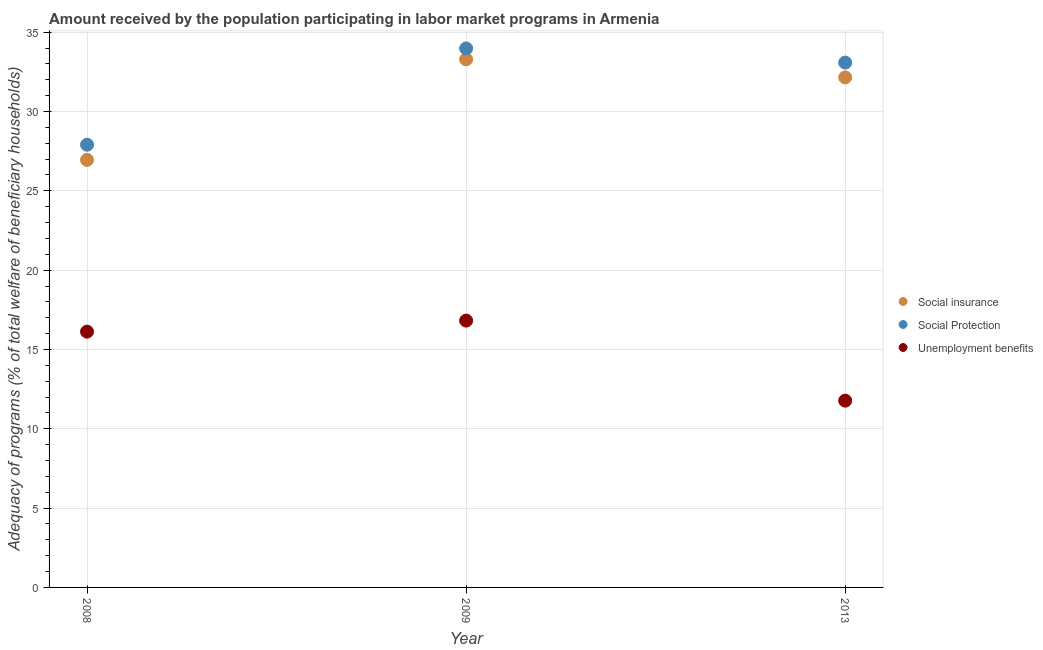How many different coloured dotlines are there?
Make the answer very short. 3. What is the amount received by the population participating in unemployment benefits programs in 2008?
Your answer should be very brief. 16.12. Across all years, what is the maximum amount received by the population participating in social insurance programs?
Your answer should be very brief. 33.29. Across all years, what is the minimum amount received by the population participating in social protection programs?
Your answer should be very brief. 27.91. In which year was the amount received by the population participating in unemployment benefits programs maximum?
Give a very brief answer. 2009. In which year was the amount received by the population participating in social insurance programs minimum?
Your response must be concise. 2008. What is the total amount received by the population participating in social protection programs in the graph?
Make the answer very short. 94.97. What is the difference between the amount received by the population participating in social protection programs in 2009 and that in 2013?
Give a very brief answer. 0.89. What is the difference between the amount received by the population participating in unemployment benefits programs in 2013 and the amount received by the population participating in social protection programs in 2008?
Provide a short and direct response. -16.13. What is the average amount received by the population participating in social insurance programs per year?
Offer a terse response. 30.8. In the year 2013, what is the difference between the amount received by the population participating in unemployment benefits programs and amount received by the population participating in social insurance programs?
Ensure brevity in your answer.  -20.37. In how many years, is the amount received by the population participating in social insurance programs greater than 12 %?
Your answer should be very brief. 3. What is the ratio of the amount received by the population participating in unemployment benefits programs in 2008 to that in 2009?
Offer a terse response. 0.96. Is the amount received by the population participating in social protection programs in 2008 less than that in 2009?
Your answer should be very brief. Yes. Is the difference between the amount received by the population participating in social insurance programs in 2008 and 2013 greater than the difference between the amount received by the population participating in unemployment benefits programs in 2008 and 2013?
Make the answer very short. No. What is the difference between the highest and the second highest amount received by the population participating in social protection programs?
Keep it short and to the point. 0.89. What is the difference between the highest and the lowest amount received by the population participating in social insurance programs?
Keep it short and to the point. 6.34. In how many years, is the amount received by the population participating in unemployment benefits programs greater than the average amount received by the population participating in unemployment benefits programs taken over all years?
Offer a very short reply. 2. Is the sum of the amount received by the population participating in social insurance programs in 2009 and 2013 greater than the maximum amount received by the population participating in unemployment benefits programs across all years?
Offer a terse response. Yes. Does the amount received by the population participating in unemployment benefits programs monotonically increase over the years?
Make the answer very short. No. Is the amount received by the population participating in social insurance programs strictly greater than the amount received by the population participating in unemployment benefits programs over the years?
Give a very brief answer. Yes. Is the amount received by the population participating in social insurance programs strictly less than the amount received by the population participating in unemployment benefits programs over the years?
Ensure brevity in your answer.  No. How many dotlines are there?
Make the answer very short. 3. What is the difference between two consecutive major ticks on the Y-axis?
Keep it short and to the point. 5. Does the graph contain any zero values?
Ensure brevity in your answer.  No. What is the title of the graph?
Your answer should be compact. Amount received by the population participating in labor market programs in Armenia. What is the label or title of the X-axis?
Your answer should be very brief. Year. What is the label or title of the Y-axis?
Offer a very short reply. Adequacy of programs (% of total welfare of beneficiary households). What is the Adequacy of programs (% of total welfare of beneficiary households) in Social insurance in 2008?
Make the answer very short. 26.95. What is the Adequacy of programs (% of total welfare of beneficiary households) in Social Protection in 2008?
Provide a short and direct response. 27.91. What is the Adequacy of programs (% of total welfare of beneficiary households) in Unemployment benefits in 2008?
Provide a succinct answer. 16.12. What is the Adequacy of programs (% of total welfare of beneficiary households) in Social insurance in 2009?
Your answer should be very brief. 33.29. What is the Adequacy of programs (% of total welfare of beneficiary households) of Social Protection in 2009?
Ensure brevity in your answer.  33.98. What is the Adequacy of programs (% of total welfare of beneficiary households) in Unemployment benefits in 2009?
Offer a terse response. 16.82. What is the Adequacy of programs (% of total welfare of beneficiary households) in Social insurance in 2013?
Offer a terse response. 32.15. What is the Adequacy of programs (% of total welfare of beneficiary households) of Social Protection in 2013?
Make the answer very short. 33.08. What is the Adequacy of programs (% of total welfare of beneficiary households) in Unemployment benefits in 2013?
Give a very brief answer. 11.77. Across all years, what is the maximum Adequacy of programs (% of total welfare of beneficiary households) in Social insurance?
Provide a short and direct response. 33.29. Across all years, what is the maximum Adequacy of programs (% of total welfare of beneficiary households) in Social Protection?
Your response must be concise. 33.98. Across all years, what is the maximum Adequacy of programs (% of total welfare of beneficiary households) of Unemployment benefits?
Your response must be concise. 16.82. Across all years, what is the minimum Adequacy of programs (% of total welfare of beneficiary households) in Social insurance?
Offer a terse response. 26.95. Across all years, what is the minimum Adequacy of programs (% of total welfare of beneficiary households) of Social Protection?
Make the answer very short. 27.91. Across all years, what is the minimum Adequacy of programs (% of total welfare of beneficiary households) of Unemployment benefits?
Keep it short and to the point. 11.77. What is the total Adequacy of programs (% of total welfare of beneficiary households) in Social insurance in the graph?
Your answer should be compact. 92.39. What is the total Adequacy of programs (% of total welfare of beneficiary households) in Social Protection in the graph?
Your answer should be very brief. 94.97. What is the total Adequacy of programs (% of total welfare of beneficiary households) in Unemployment benefits in the graph?
Offer a terse response. 44.72. What is the difference between the Adequacy of programs (% of total welfare of beneficiary households) in Social insurance in 2008 and that in 2009?
Your answer should be compact. -6.34. What is the difference between the Adequacy of programs (% of total welfare of beneficiary households) in Social Protection in 2008 and that in 2009?
Your response must be concise. -6.07. What is the difference between the Adequacy of programs (% of total welfare of beneficiary households) in Unemployment benefits in 2008 and that in 2009?
Your response must be concise. -0.7. What is the difference between the Adequacy of programs (% of total welfare of beneficiary households) of Social insurance in 2008 and that in 2013?
Provide a short and direct response. -5.2. What is the difference between the Adequacy of programs (% of total welfare of beneficiary households) of Social Protection in 2008 and that in 2013?
Offer a terse response. -5.18. What is the difference between the Adequacy of programs (% of total welfare of beneficiary households) in Unemployment benefits in 2008 and that in 2013?
Give a very brief answer. 4.35. What is the difference between the Adequacy of programs (% of total welfare of beneficiary households) of Social insurance in 2009 and that in 2013?
Your response must be concise. 1.14. What is the difference between the Adequacy of programs (% of total welfare of beneficiary households) of Social Protection in 2009 and that in 2013?
Your answer should be very brief. 0.89. What is the difference between the Adequacy of programs (% of total welfare of beneficiary households) in Unemployment benefits in 2009 and that in 2013?
Keep it short and to the point. 5.05. What is the difference between the Adequacy of programs (% of total welfare of beneficiary households) of Social insurance in 2008 and the Adequacy of programs (% of total welfare of beneficiary households) of Social Protection in 2009?
Provide a short and direct response. -7.03. What is the difference between the Adequacy of programs (% of total welfare of beneficiary households) of Social insurance in 2008 and the Adequacy of programs (% of total welfare of beneficiary households) of Unemployment benefits in 2009?
Give a very brief answer. 10.13. What is the difference between the Adequacy of programs (% of total welfare of beneficiary households) in Social Protection in 2008 and the Adequacy of programs (% of total welfare of beneficiary households) in Unemployment benefits in 2009?
Your answer should be very brief. 11.09. What is the difference between the Adequacy of programs (% of total welfare of beneficiary households) in Social insurance in 2008 and the Adequacy of programs (% of total welfare of beneficiary households) in Social Protection in 2013?
Give a very brief answer. -6.14. What is the difference between the Adequacy of programs (% of total welfare of beneficiary households) in Social insurance in 2008 and the Adequacy of programs (% of total welfare of beneficiary households) in Unemployment benefits in 2013?
Keep it short and to the point. 15.17. What is the difference between the Adequacy of programs (% of total welfare of beneficiary households) of Social Protection in 2008 and the Adequacy of programs (% of total welfare of beneficiary households) of Unemployment benefits in 2013?
Your answer should be very brief. 16.13. What is the difference between the Adequacy of programs (% of total welfare of beneficiary households) in Social insurance in 2009 and the Adequacy of programs (% of total welfare of beneficiary households) in Social Protection in 2013?
Your answer should be very brief. 0.21. What is the difference between the Adequacy of programs (% of total welfare of beneficiary households) of Social insurance in 2009 and the Adequacy of programs (% of total welfare of beneficiary households) of Unemployment benefits in 2013?
Offer a very short reply. 21.52. What is the difference between the Adequacy of programs (% of total welfare of beneficiary households) in Social Protection in 2009 and the Adequacy of programs (% of total welfare of beneficiary households) in Unemployment benefits in 2013?
Your answer should be compact. 22.2. What is the average Adequacy of programs (% of total welfare of beneficiary households) in Social insurance per year?
Offer a terse response. 30.8. What is the average Adequacy of programs (% of total welfare of beneficiary households) of Social Protection per year?
Offer a very short reply. 31.66. What is the average Adequacy of programs (% of total welfare of beneficiary households) in Unemployment benefits per year?
Make the answer very short. 14.91. In the year 2008, what is the difference between the Adequacy of programs (% of total welfare of beneficiary households) in Social insurance and Adequacy of programs (% of total welfare of beneficiary households) in Social Protection?
Offer a very short reply. -0.96. In the year 2008, what is the difference between the Adequacy of programs (% of total welfare of beneficiary households) of Social insurance and Adequacy of programs (% of total welfare of beneficiary households) of Unemployment benefits?
Ensure brevity in your answer.  10.82. In the year 2008, what is the difference between the Adequacy of programs (% of total welfare of beneficiary households) of Social Protection and Adequacy of programs (% of total welfare of beneficiary households) of Unemployment benefits?
Ensure brevity in your answer.  11.78. In the year 2009, what is the difference between the Adequacy of programs (% of total welfare of beneficiary households) in Social insurance and Adequacy of programs (% of total welfare of beneficiary households) in Social Protection?
Give a very brief answer. -0.69. In the year 2009, what is the difference between the Adequacy of programs (% of total welfare of beneficiary households) in Social insurance and Adequacy of programs (% of total welfare of beneficiary households) in Unemployment benefits?
Your answer should be very brief. 16.47. In the year 2009, what is the difference between the Adequacy of programs (% of total welfare of beneficiary households) of Social Protection and Adequacy of programs (% of total welfare of beneficiary households) of Unemployment benefits?
Give a very brief answer. 17.16. In the year 2013, what is the difference between the Adequacy of programs (% of total welfare of beneficiary households) of Social insurance and Adequacy of programs (% of total welfare of beneficiary households) of Social Protection?
Give a very brief answer. -0.94. In the year 2013, what is the difference between the Adequacy of programs (% of total welfare of beneficiary households) in Social insurance and Adequacy of programs (% of total welfare of beneficiary households) in Unemployment benefits?
Offer a terse response. 20.37. In the year 2013, what is the difference between the Adequacy of programs (% of total welfare of beneficiary households) in Social Protection and Adequacy of programs (% of total welfare of beneficiary households) in Unemployment benefits?
Provide a succinct answer. 21.31. What is the ratio of the Adequacy of programs (% of total welfare of beneficiary households) of Social insurance in 2008 to that in 2009?
Your answer should be very brief. 0.81. What is the ratio of the Adequacy of programs (% of total welfare of beneficiary households) of Social Protection in 2008 to that in 2009?
Give a very brief answer. 0.82. What is the ratio of the Adequacy of programs (% of total welfare of beneficiary households) of Unemployment benefits in 2008 to that in 2009?
Your answer should be compact. 0.96. What is the ratio of the Adequacy of programs (% of total welfare of beneficiary households) in Social insurance in 2008 to that in 2013?
Your answer should be very brief. 0.84. What is the ratio of the Adequacy of programs (% of total welfare of beneficiary households) of Social Protection in 2008 to that in 2013?
Offer a terse response. 0.84. What is the ratio of the Adequacy of programs (% of total welfare of beneficiary households) of Unemployment benefits in 2008 to that in 2013?
Ensure brevity in your answer.  1.37. What is the ratio of the Adequacy of programs (% of total welfare of beneficiary households) in Social insurance in 2009 to that in 2013?
Offer a very short reply. 1.04. What is the ratio of the Adequacy of programs (% of total welfare of beneficiary households) in Social Protection in 2009 to that in 2013?
Offer a very short reply. 1.03. What is the ratio of the Adequacy of programs (% of total welfare of beneficiary households) in Unemployment benefits in 2009 to that in 2013?
Offer a terse response. 1.43. What is the difference between the highest and the second highest Adequacy of programs (% of total welfare of beneficiary households) of Social insurance?
Offer a very short reply. 1.14. What is the difference between the highest and the second highest Adequacy of programs (% of total welfare of beneficiary households) of Social Protection?
Ensure brevity in your answer.  0.89. What is the difference between the highest and the second highest Adequacy of programs (% of total welfare of beneficiary households) of Unemployment benefits?
Ensure brevity in your answer.  0.7. What is the difference between the highest and the lowest Adequacy of programs (% of total welfare of beneficiary households) in Social insurance?
Ensure brevity in your answer.  6.34. What is the difference between the highest and the lowest Adequacy of programs (% of total welfare of beneficiary households) of Social Protection?
Your response must be concise. 6.07. What is the difference between the highest and the lowest Adequacy of programs (% of total welfare of beneficiary households) of Unemployment benefits?
Ensure brevity in your answer.  5.05. 